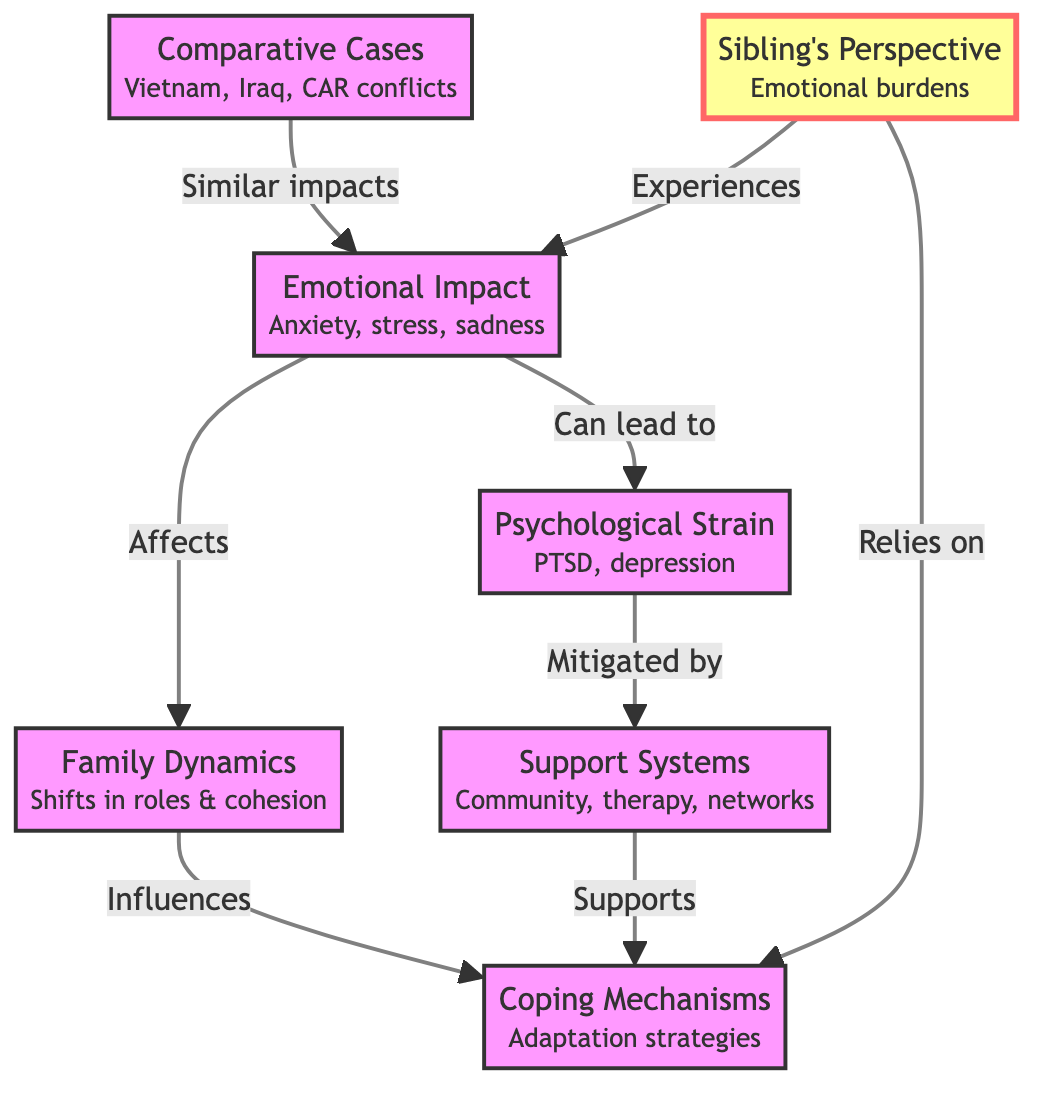What are the emotional impacts mentioned in the diagram? The diagram lists "Anxiety, stress, sadness" under the Emotional Impact section, directly answering the question about the emotional effects.
Answer: Anxiety, stress, sadness How many main areas are identified in the diagram? Upon examining the diagram, there are seven main areas represented, which are Emotional Impact, Psychological Strain, Family Dynamics, Support Systems, Comparative Cases, Coping Mechanisms, and Sibling's Perspective.
Answer: 7 What factors can mitigate psychological strain according to the diagram? The diagram notes that psychological strain, as represented by PTSD and depression, can be mitigated by support systems such as community, therapy, and networks.
Answer: Support Systems What influences coping mechanisms as per the diagram? The diagram indicates that family dynamics, which include shifts in roles and cohesion, influence coping mechanisms. This means the changes within families can affect how they adapt.
Answer: Family Dynamics What is indicated as a sibling's experience? The diagram describes the sibling's perspective as experiencing emotional burdens, which implies that siblings carry their own emotional weight due to the deployment of their soldier family member.
Answer: Emotional burdens Which conflict cases are considered in the comparative analysis? The diagram includes Vietnam, Iraq, and CAR conflicts as the comparative cases that illustrate similar emotional impacts on families of deployed soldiers.
Answer: Vietnam, Iraq, CAR conflicts How are coping mechanisms supported according to the diagram? The diagram shows that coping mechanisms are supported by both support systems and family dynamics, suggesting that these areas provide necessary assistance for adaptation.
Answer: Support Systems and Family Dynamics What is the relationship between emotional impacts and psychological strain? The diagram indicates that emotional impacts can lead to psychological strain, showing a direct connection in how one influences the other.
Answer: Can lead to What role do support systems play in the context of psychological strain? According to the diagram, support systems mitigate psychological strain, meaning they help lessen the impact of mental health issues experienced by families.
Answer: Mitigated by 